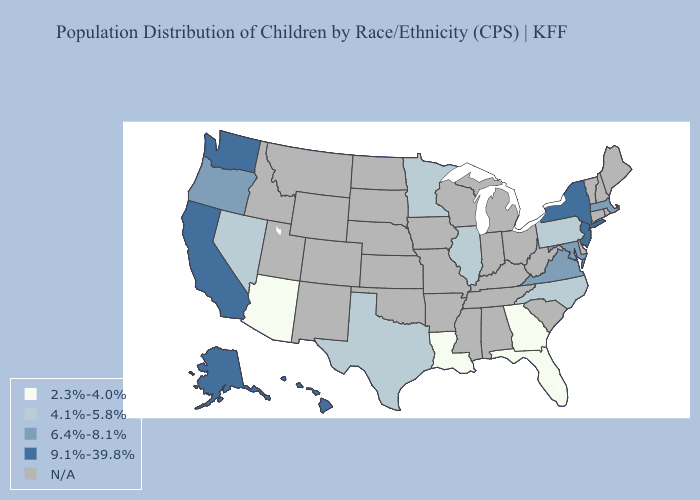What is the lowest value in the MidWest?
Concise answer only. 4.1%-5.8%. What is the value of South Carolina?
Keep it brief. N/A. Name the states that have a value in the range N/A?
Write a very short answer. Alabama, Arkansas, Colorado, Connecticut, Delaware, Idaho, Indiana, Iowa, Kansas, Kentucky, Maine, Michigan, Mississippi, Missouri, Montana, Nebraska, New Hampshire, New Mexico, North Dakota, Ohio, Oklahoma, Rhode Island, South Carolina, South Dakota, Tennessee, Utah, Vermont, West Virginia, Wisconsin, Wyoming. Name the states that have a value in the range 6.4%-8.1%?
Answer briefly. Maryland, Massachusetts, Oregon, Virginia. Name the states that have a value in the range N/A?
Short answer required. Alabama, Arkansas, Colorado, Connecticut, Delaware, Idaho, Indiana, Iowa, Kansas, Kentucky, Maine, Michigan, Mississippi, Missouri, Montana, Nebraska, New Hampshire, New Mexico, North Dakota, Ohio, Oklahoma, Rhode Island, South Carolina, South Dakota, Tennessee, Utah, Vermont, West Virginia, Wisconsin, Wyoming. Which states hav the highest value in the Northeast?
Keep it brief. New Jersey, New York. Does Pennsylvania have the lowest value in the Northeast?
Quick response, please. Yes. Which states have the lowest value in the USA?
Concise answer only. Arizona, Florida, Georgia, Louisiana. Name the states that have a value in the range 4.1%-5.8%?
Keep it brief. Illinois, Minnesota, Nevada, North Carolina, Pennsylvania, Texas. Name the states that have a value in the range N/A?
Keep it brief. Alabama, Arkansas, Colorado, Connecticut, Delaware, Idaho, Indiana, Iowa, Kansas, Kentucky, Maine, Michigan, Mississippi, Missouri, Montana, Nebraska, New Hampshire, New Mexico, North Dakota, Ohio, Oklahoma, Rhode Island, South Carolina, South Dakota, Tennessee, Utah, Vermont, West Virginia, Wisconsin, Wyoming. 